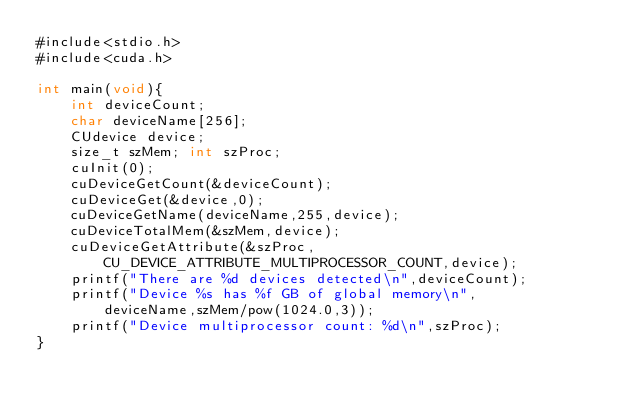Convert code to text. <code><loc_0><loc_0><loc_500><loc_500><_Cuda_>#include<stdio.h>
#include<cuda.h>

int main(void){
    int deviceCount; 
    char deviceName[256];
    CUdevice device;
    size_t szMem; int szProc;
    cuInit(0);
    cuDeviceGetCount(&deviceCount);
    cuDeviceGet(&device,0);
    cuDeviceGetName(deviceName,255,device);
    cuDeviceTotalMem(&szMem,device);
    cuDeviceGetAttribute(&szProc,CU_DEVICE_ATTRIBUTE_MULTIPROCESSOR_COUNT,device);
    printf("There are %d devices detected\n",deviceCount);
    printf("Device %s has %f GB of global memory\n",
        deviceName,szMem/pow(1024.0,3));
    printf("Device multiprocessor count: %d\n",szProc);
}
</code> 